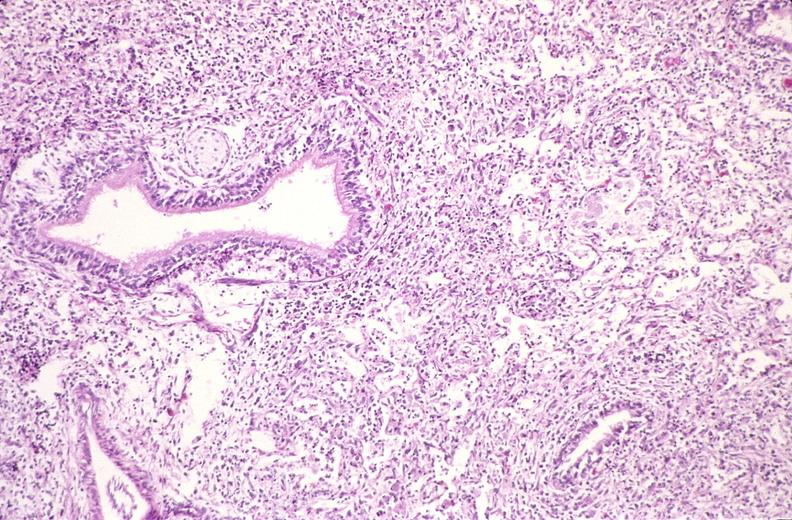s intraductal papillomatosis present?
Answer the question using a single word or phrase. No 